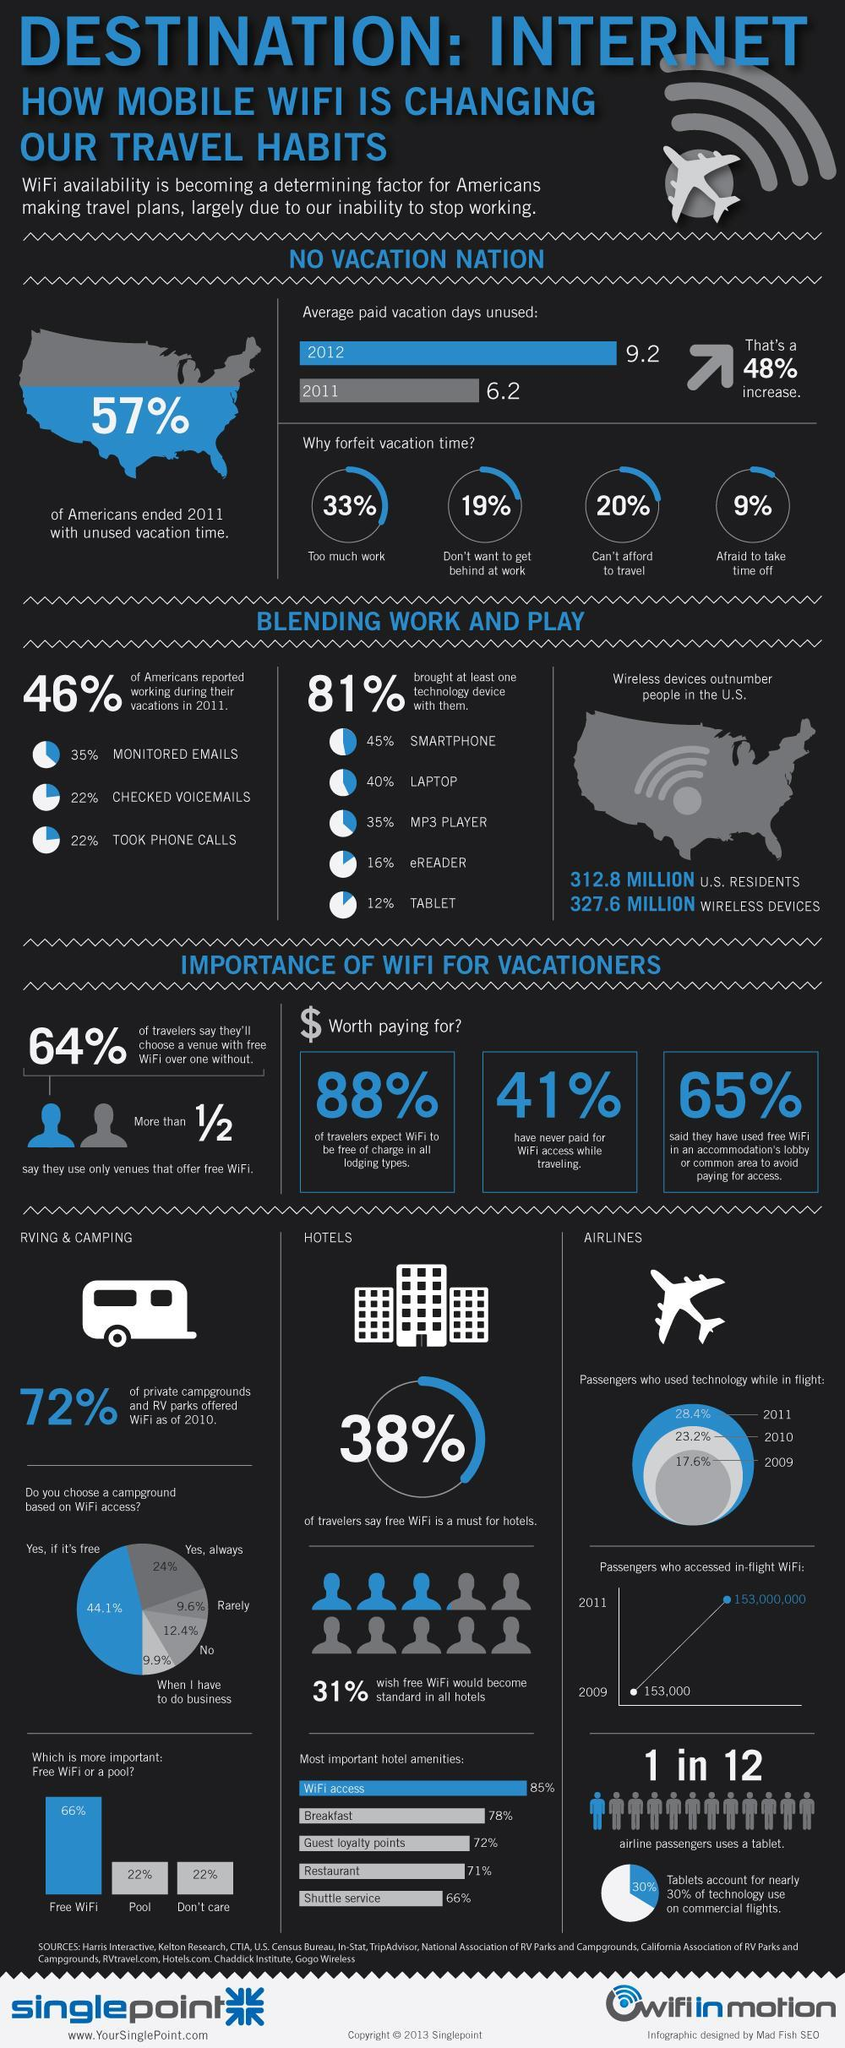Which has the highest share-"yes, always" or "yes, if it's free"?
Answer the question with a short phrase. yes, if it's free What percentage of people paid for Wifi access while traveling? 59% What is the percentage of breakfast and restaurant, taken together? 149% What is the percentage of free wifi and pool, taken together? 88% What percentage of Americans used vacation time of 2011 effectively? 43% 